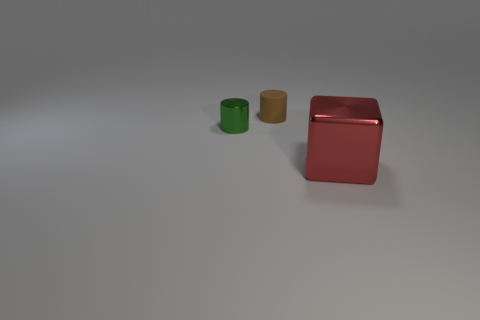What is the color of the tiny thing that is the same material as the red block?
Offer a very short reply. Green. There is a shiny object that is in front of the small cylinder that is in front of the cylinder that is on the right side of the green object; what color is it?
Your answer should be very brief. Red. Do the red metallic object and the metal thing behind the large block have the same size?
Give a very brief answer. No. How many objects are either metallic objects that are left of the large block or metal objects that are to the right of the small brown matte object?
Your answer should be very brief. 2. The other shiny thing that is the same size as the brown object is what shape?
Your response must be concise. Cylinder. There is a shiny thing behind the big red cube right of the shiny object behind the red object; what is its shape?
Provide a succinct answer. Cylinder. Is the number of cubes behind the brown rubber thing the same as the number of green cylinders?
Provide a succinct answer. No. Is the size of the green thing the same as the red cube?
Provide a succinct answer. No. How many rubber things are either brown things or red objects?
Provide a short and direct response. 1. There is a green cylinder that is the same size as the matte object; what material is it?
Keep it short and to the point. Metal. 